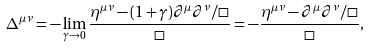Convert formula to latex. <formula><loc_0><loc_0><loc_500><loc_500>\Delta ^ { \mu \nu } = - \lim _ { \gamma \rightarrow 0 } \frac { \eta ^ { \mu \nu } - ( 1 + \gamma ) \partial ^ { \mu } \partial ^ { \nu } / \square } { \square } = - \frac { \eta ^ { \mu \nu } - \partial ^ { \mu } \partial ^ { \nu } / \square } { \square } ,</formula> 